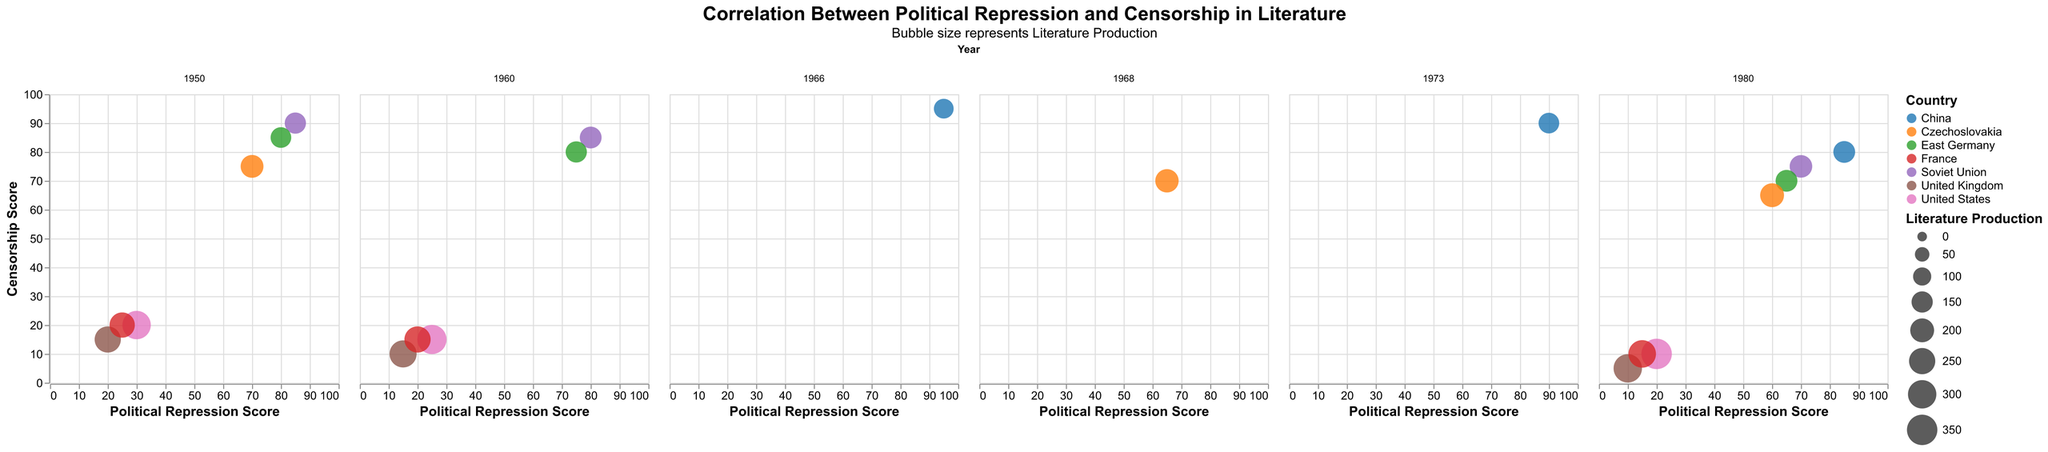Which country has the highest combination of Political Repression and Censorship scores in 1950? Look at the 1950 column and compare the scores for each country. The Soviet Union has the highest scores (85 for Political Repression and 90 for Censorship).
Answer: Soviet Union Which country had the greatest increase in Literature Production between 1960 and 1980? Compare the Literature Production in 1960 and 1980 for each country and find the difference. The United States increased from 320 to 350, a difference of 30, which is the highest.
Answer: United States In 1980, which country had the lowest Political Repression score? Look at the 1980 column and compare the Political Repression scores. The United Kingdom has the lowest score of 10.
Answer: United Kingdom How does Political Repression relate to Censorship score in the United States over time? Observe the trend of Political Repression and Censorship scores for the United States over the years 1950, 1960, and 1980. Both scores decrease over time.
Answer: Both decrease How many nations are included in the plot for the year 1960? Count the number of unique countries listed in the 1960 column. There are 7 nations (Soviet Union, United States, East Germany, Czechoslovakia, United Kingdom, France, China).
Answer: 7 Which country shows the most significant change in Political Repression score from 1950 to 1980? Calculate the change in Political Repression score for each country between 1950 and 1980. China has the biggest reduction from 95 in 1966 to 85 in 1980, even though their metrics start from different years.
Answer: China Does the bubble size indicate higher or lower Literature Production in the Soviet Union in 1980 compared to 1950? Compare the bubble sizes for the Soviet Union in 1980 and 1950. The 1980 bubble is larger, indicating higher Literature Production.
Answer: Higher Which country had a Political Repression score of 60 and a Censorship score of 65 in 1980? Look at the 1980 column and find the country with these scores. Czechoslovakia matches the criteria.
Answer: Czechoslovakia 